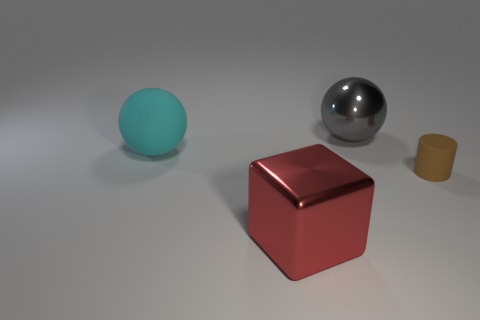Add 4 small red cylinders. How many objects exist? 8 Subtract all blocks. How many objects are left? 3 Add 3 big red shiny things. How many big red shiny things are left? 4 Add 4 gray spheres. How many gray spheres exist? 5 Subtract 0 brown cubes. How many objects are left? 4 Subtract all big cyan spheres. Subtract all metal objects. How many objects are left? 1 